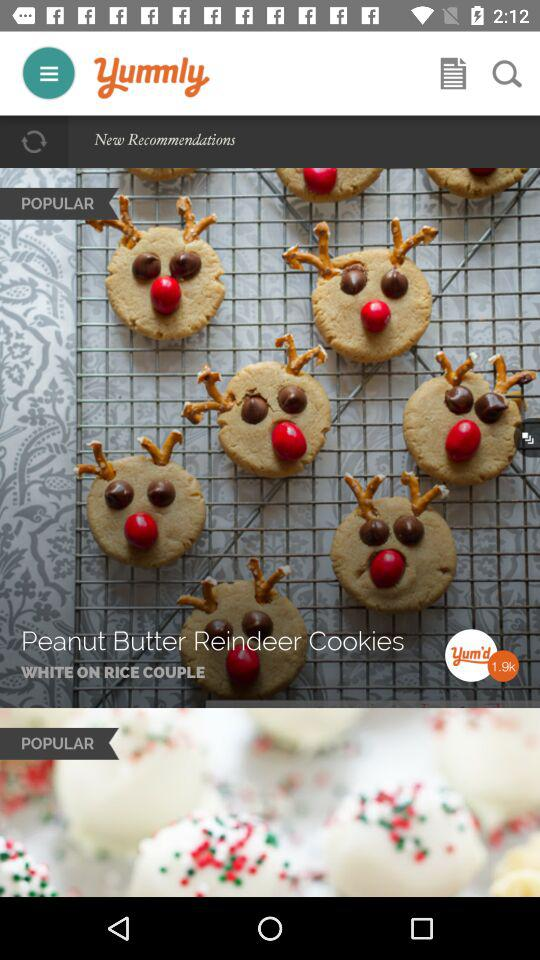How many people voted for the "Peanut Butter Reindeer Cookies"? The number of people who voted for the "Peanut Butter Reindeer Cookies" is 1.9k. 